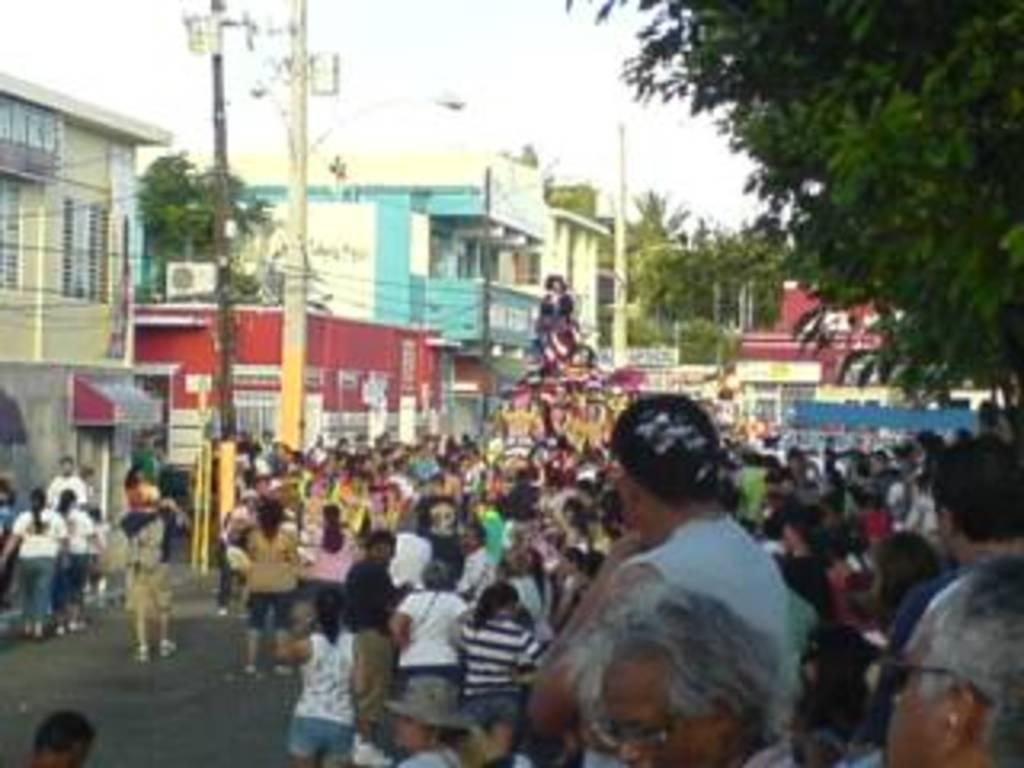Describe this image in one or two sentences. In this picture we can see a group of people, trees, buildings, electric poles and some objects and in the background we can see the sky. 